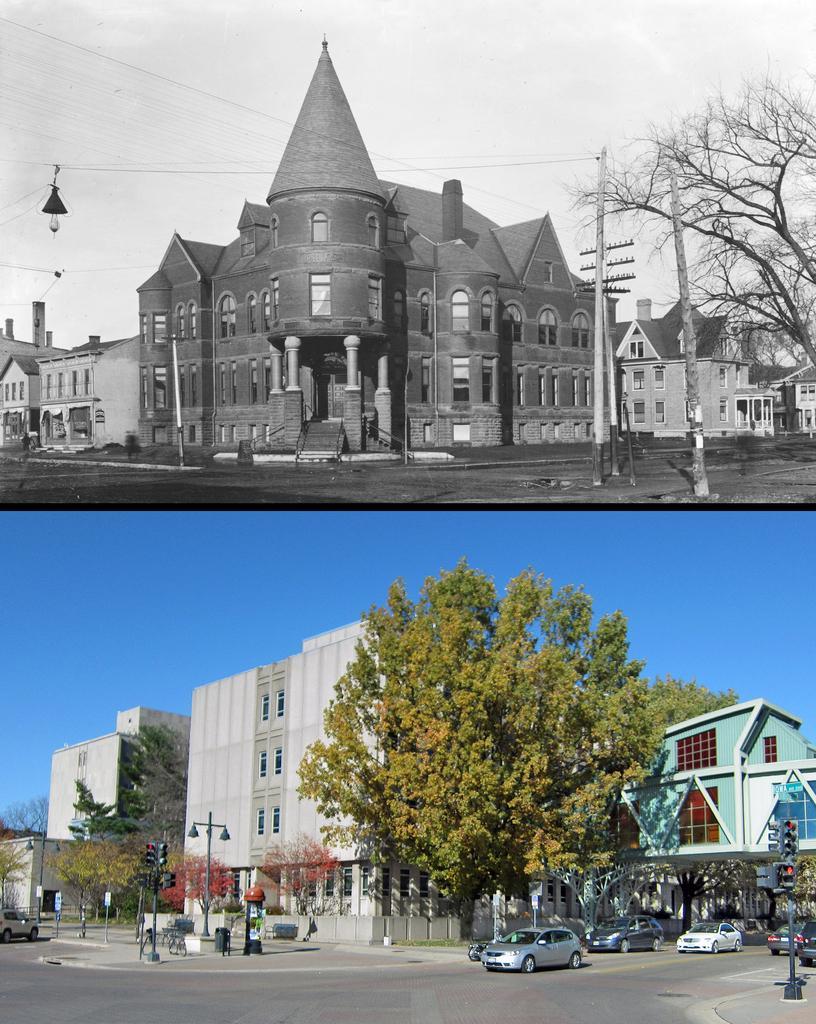Could you give a brief overview of what you see in this image? In the foreground I can see fleets of cars, poles, wires, trees on the road and buildings. In the background I can see the sky. This image is taken during a day. 